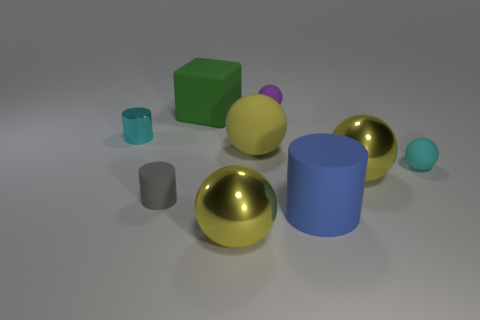Can you identify and describe the objects that exhibit reflective surfaces? Certainly! In the image, the objects with reflective surfaces are the two gold spheres with a shiny, mirrored finish that beautifully reflects the surrounding scene. Additionally, the larger light blue cylinder on the right also appears to have a somewhat reflective surface, although it's less pronounced compared to the gold spheres. 